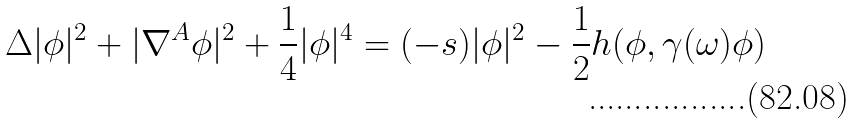Convert formula to latex. <formula><loc_0><loc_0><loc_500><loc_500>\Delta | \phi | ^ { 2 } + | \nabla ^ { A } \phi | ^ { 2 } + { \frac { 1 } { 4 } } | \phi | ^ { 4 } = ( - s ) | \phi | ^ { 2 } - { \frac { 1 } { 2 } } h ( \phi , \gamma ( \omega ) \phi )</formula> 